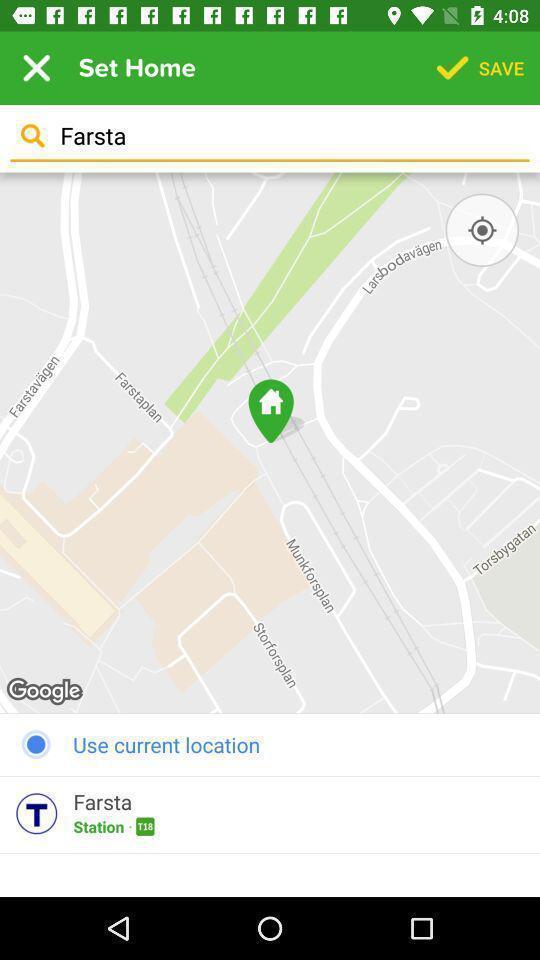Explain what's happening in this screen capture. Search bar for searching the location in navigation app. 